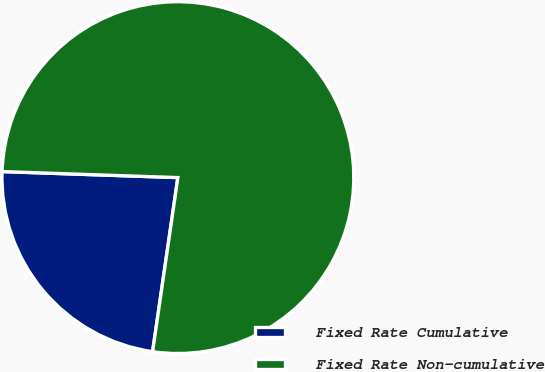<chart> <loc_0><loc_0><loc_500><loc_500><pie_chart><fcel>Fixed Rate Cumulative<fcel>Fixed Rate Non-cumulative<nl><fcel>23.25%<fcel>76.75%<nl></chart> 